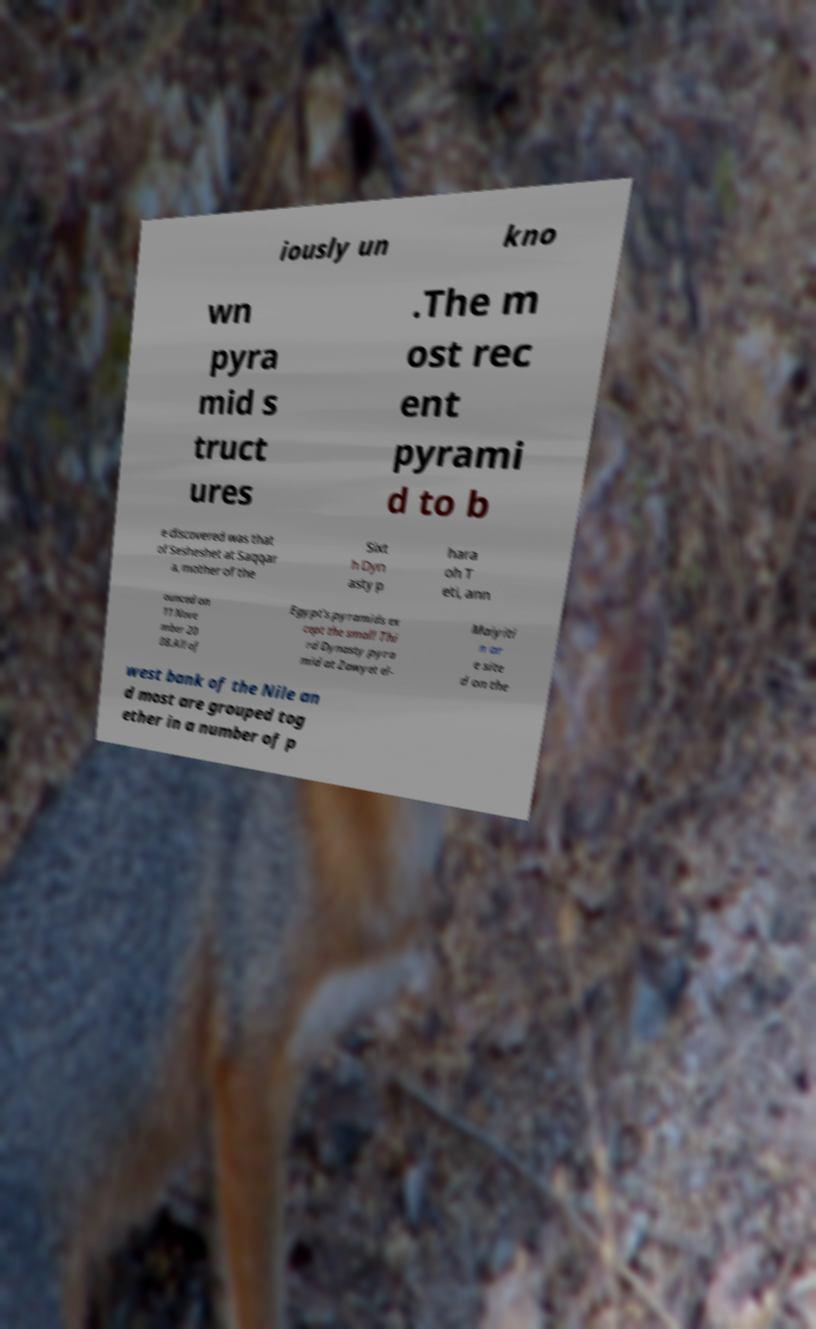Please read and relay the text visible in this image. What does it say? iously un kno wn pyra mid s truct ures .The m ost rec ent pyrami d to b e discovered was that of Sesheshet at Saqqar a, mother of the Sixt h Dyn asty p hara oh T eti, ann ounced on 11 Nove mber 20 08.All of Egypt's pyramids ex cept the small Thi rd Dynasty pyra mid at Zawyet el- Maiyiti n ar e site d on the west bank of the Nile an d most are grouped tog ether in a number of p 